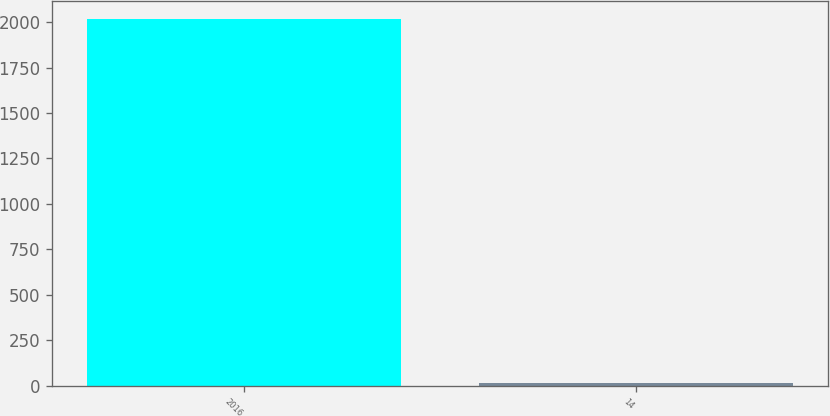Convert chart. <chart><loc_0><loc_0><loc_500><loc_500><bar_chart><fcel>2016<fcel>14<nl><fcel>2017<fcel>14<nl></chart> 